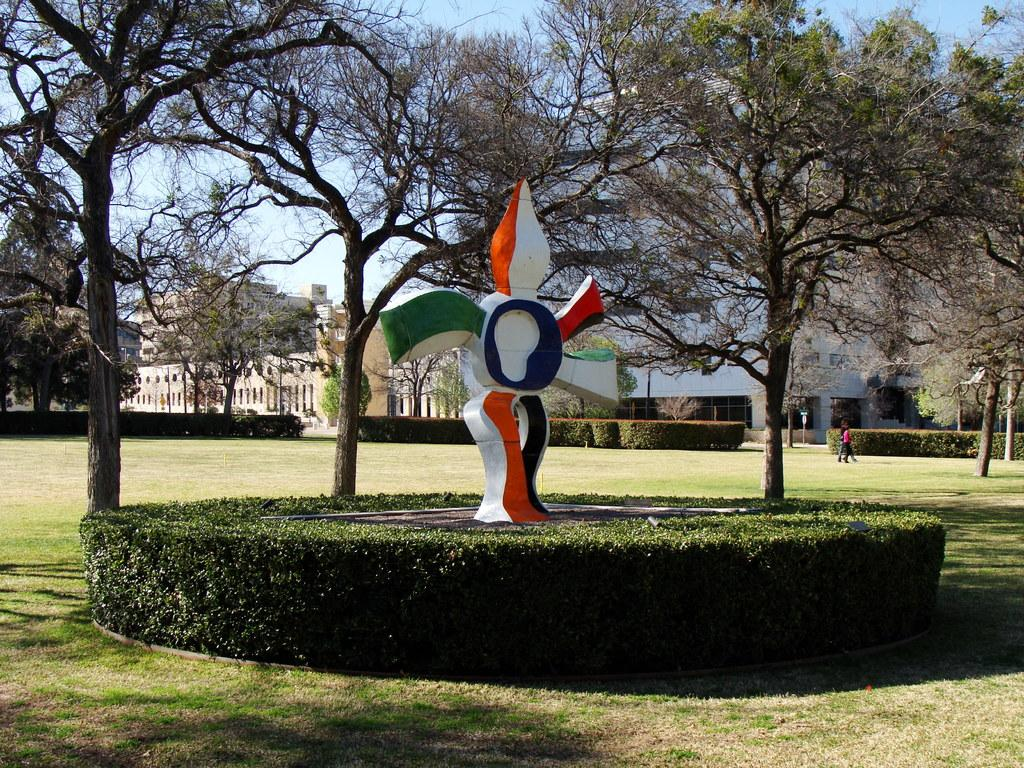What type of outdoor space is depicted in the image? There is a garden in the image. What can be seen in the foreground of the garden? There is a sculpture in the foreground of the garden. What type of vegetation is present around the garden? Trees and plants are present around the garden. What can be seen in the background of the image? There are buildings in the background of the image. What type of reward is being given to the plants in the garden? There is no indication in the image that the plants are receiving any reward. 